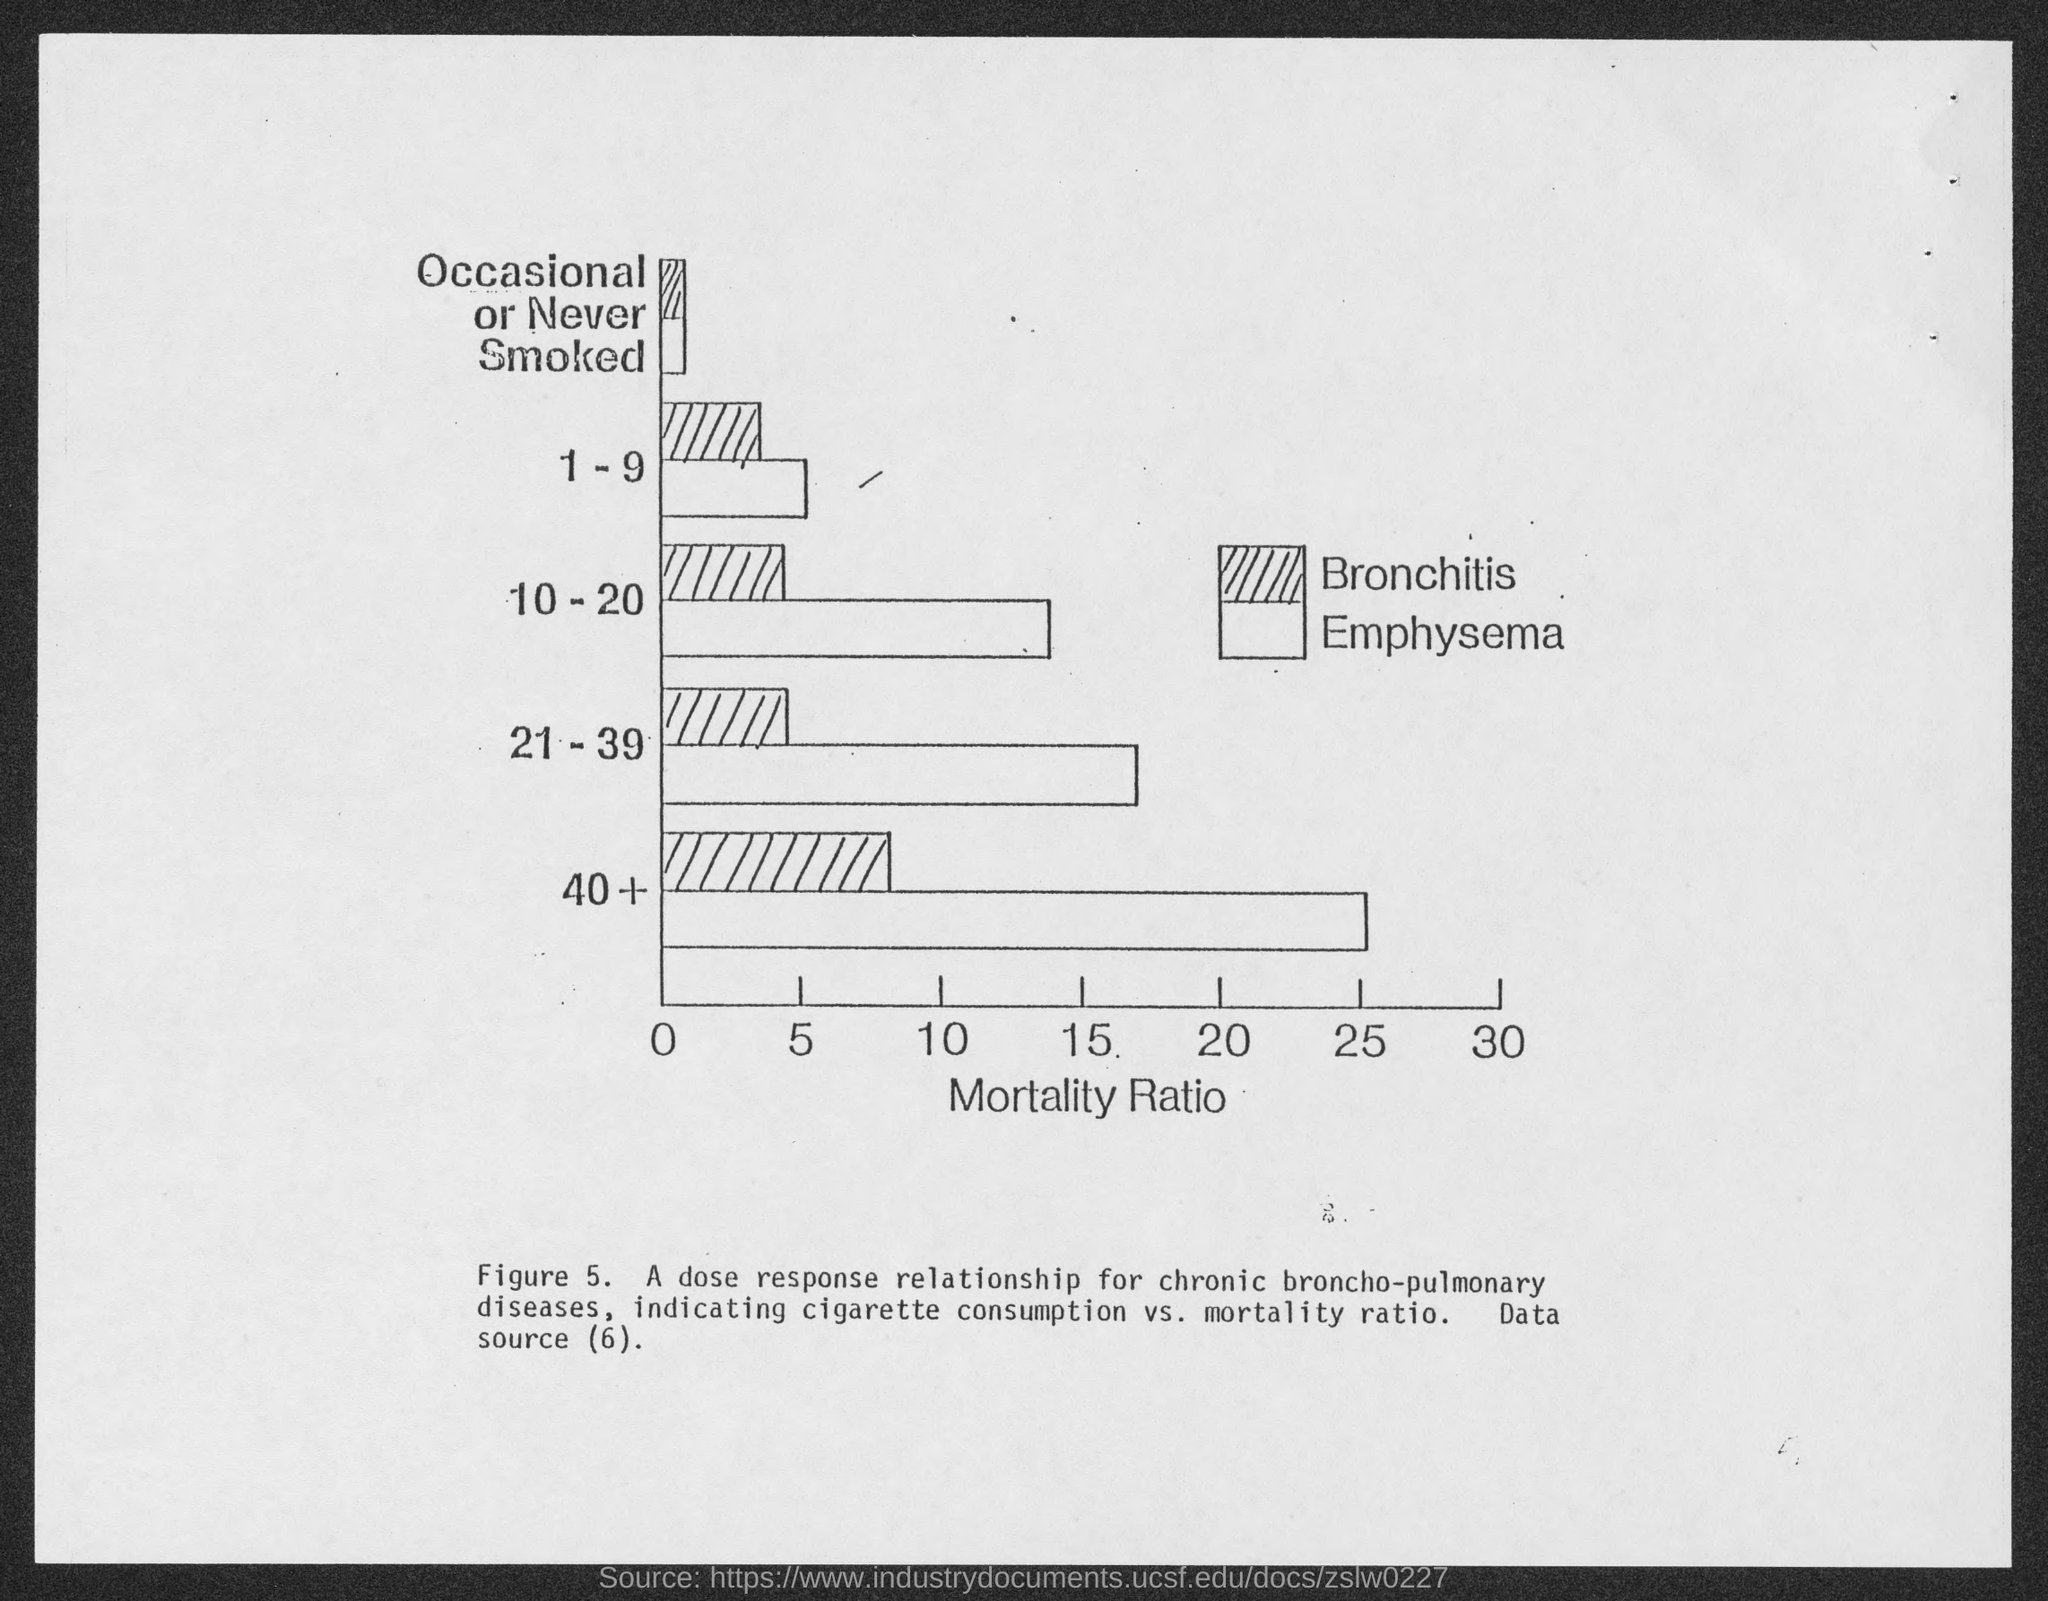What does the x-axis represent?
Your answer should be compact. Mortality Ratio. What is the figure number?
Make the answer very short. 5. 